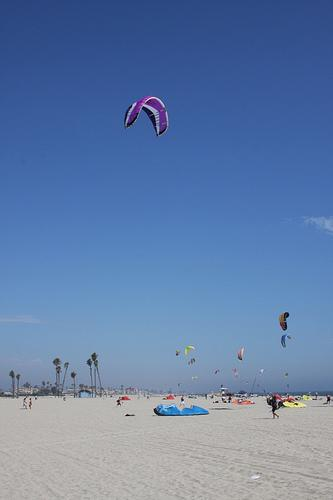What type of weather is the beach seeing today? Please explain your reasoning. wind. A kite is flying over a beach. 